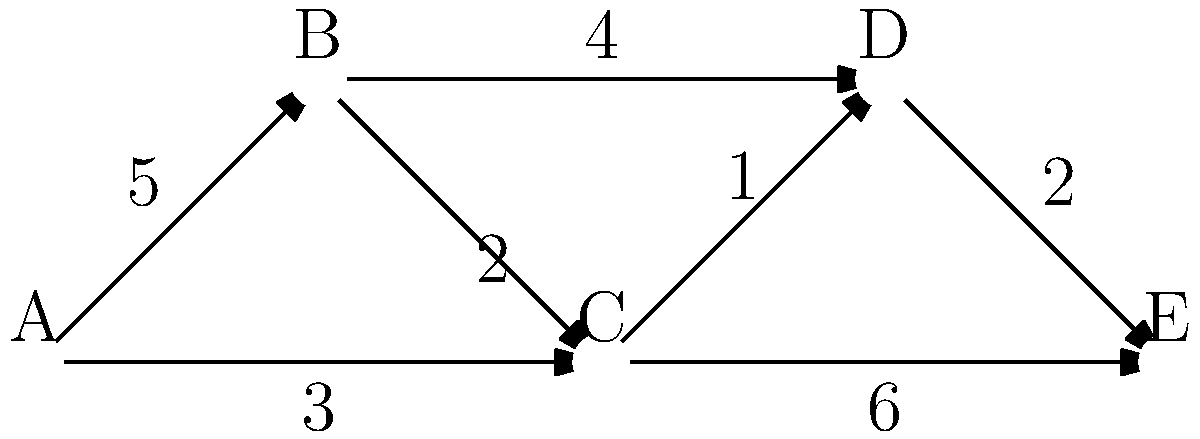As an aspiring film editor inspired by Orlee Buium's work, you're tasked with finding the most efficient way to edit a sequence of scenes. The graph represents different scenes (nodes) and the time (in minutes) it takes to transition between them (edge weights). What is the shortest path from scene A to scene E, and what is the total transition time? To find the shortest path from scene A to scene E, we'll use Dijkstra's algorithm:

1. Initialize:
   - Distance to A: 0
   - Distance to all other nodes: infinity
   - Previous node for all: undefined

2. Visit A:
   - Update B: 0 + 5 = 5
   - Update C: 0 + 3 = 3
   - Mark A as visited

3. Visit C (shortest unvisited):
   - Update B: min(5, 3 + 2) = 5
   - Update D: 3 + 1 = 4
   - Update E: 3 + 6 = 9
   - Mark C as visited

4. Visit D (shortest unvisited):
   - Update E: min(9, 4 + 2) = 6
   - Mark D as visited

5. Visit B (shortest unvisited):
   - No updates needed
   - Mark B as visited

6. Visit E (last unvisited):
   - Algorithm complete

The shortest path is A → C → D → E with a total transition time of 6 minutes.
Answer: A → C → D → E, 6 minutes 